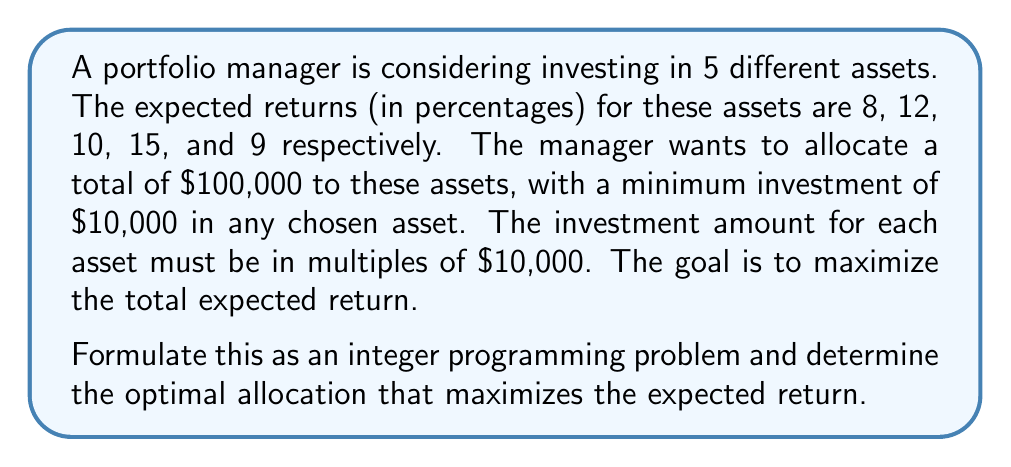Help me with this question. Let's approach this step-by-step:

1) First, we need to define our decision variables. Let $x_i$ represent the number of $10,000 units invested in asset $i$, where $i = 1, 2, 3, 4, 5$.

2) The objective function is to maximize the total expected return:

   Maximize $Z = 0.08(10000x_1) + 0.12(10000x_2) + 0.10(10000x_3) + 0.15(10000x_4) + 0.09(10000x_5)$

   This can be simplified to:

   Maximize $Z = 800x_1 + 1200x_2 + 1000x_3 + 1500x_4 + 900x_5$

3) Now, let's define our constraints:

   a) Total investment constraint:
      $10000x_1 + 10000x_2 + 10000x_3 + 10000x_4 + 10000x_5 = 100000$
      Simplified: $x_1 + x_2 + x_3 + x_4 + x_5 = 10$

   b) Minimum investment constraints:
      $x_i \geq 1$ or $x_i = 0$ for $i = 1, 2, 3, 4, 5$

   c) Integer constraints:
      $x_i$ are non-negative integers for $i = 1, 2, 3, 4, 5$

4) To solve this, we can use a branch and bound algorithm or a solver. The optimal solution is:

   $x_1 = 0, x_2 = 0, x_3 = 0, x_4 = 7, x_5 = 3$

5) This translates to:
   - $70,000 invested in asset 4
   - $30,000 invested in asset 5

6) The maximum expected return is:

   $Z = 1500(7) + 900(3) = 10500 + 2700 = 13200$

Therefore, the maximum expected return is $13,200, or 13.2% of the total investment.
Answer: The optimal allocation is to invest $70,000 in asset 4 and $30,000 in asset 5, yielding a maximum expected return of $13,200 (13.2%). 